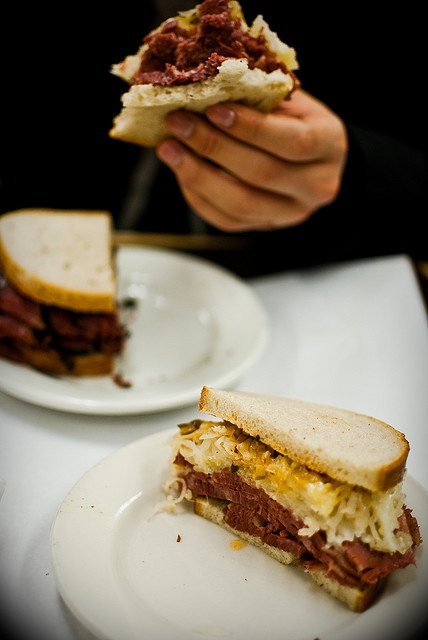Describe the objects in this image and their specific colors. I can see sandwich in black, maroon, tan, and olive tones, people in black, brown, maroon, and tan tones, sandwich in black, tan, maroon, and olive tones, and sandwich in black, maroon, olive, and tan tones in this image. 